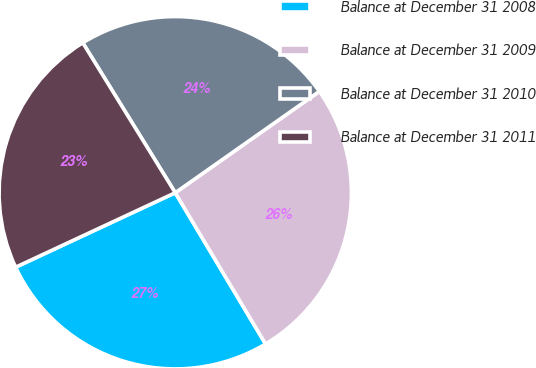Convert chart to OTSL. <chart><loc_0><loc_0><loc_500><loc_500><pie_chart><fcel>Balance at December 31 2008<fcel>Balance at December 31 2009<fcel>Balance at December 31 2010<fcel>Balance at December 31 2011<nl><fcel>26.62%<fcel>26.19%<fcel>24.04%<fcel>23.15%<nl></chart> 